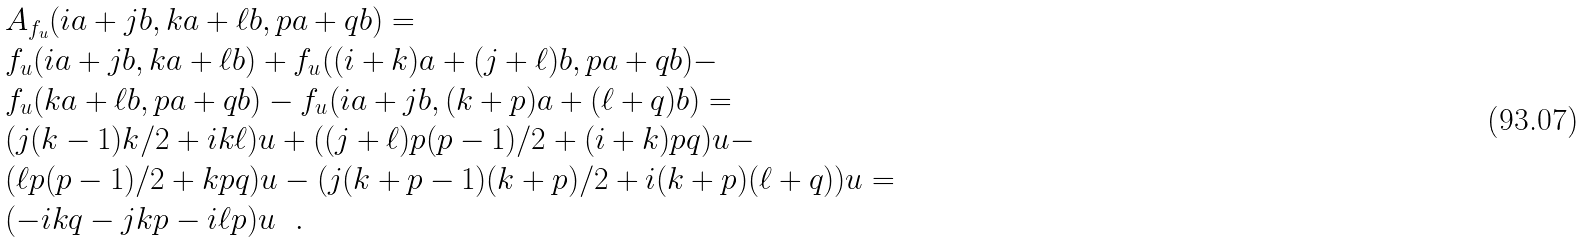<formula> <loc_0><loc_0><loc_500><loc_500>& \AA A _ { f _ { u } } ( i a + j b , k a + \ell b , p a + q b ) = \\ & f _ { u } ( i a + j b , k a + \ell b ) + f _ { u } ( ( i + k ) a + ( j + \ell ) b , p a + q b ) - \\ & f _ { u } ( k a + \ell b , p a + q b ) - f _ { u } ( i a + j b , ( k + p ) a + ( \ell + q ) b ) = \\ & ( j ( k - 1 ) k / 2 + i k \ell ) u + ( ( j + \ell ) p ( p - 1 ) / 2 + ( i + k ) p q ) u - \\ & ( \ell p ( p - 1 ) / 2 + k p q ) u - ( j ( k + p - 1 ) ( k + p ) / 2 + i ( k + p ) ( \ell + q ) ) u = \\ & ( - i k q - j k p - i \ell p ) u \ \ .</formula> 